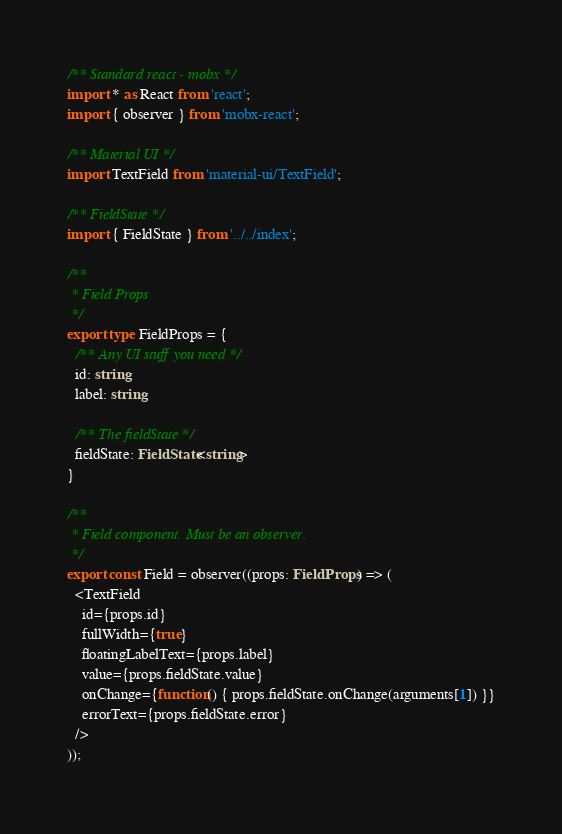<code> <loc_0><loc_0><loc_500><loc_500><_TypeScript_>/** Standard react - mobx */
import * as React from 'react';
import { observer } from 'mobx-react';

/** Material UI */
import TextField from 'material-ui/TextField';

/** FieldState */
import { FieldState } from '../../index';

/**
 * Field Props
 */
export type FieldProps = {
  /** Any UI stuff you need */
  id: string,
  label: string,

  /** The fieldState */
  fieldState: FieldState<string>
}

/**
 * Field component. Must be an observer.
 */
export const Field = observer((props: FieldProps) => (
  <TextField
    id={props.id}
    fullWidth={true}
    floatingLabelText={props.label}
    value={props.fieldState.value}
    onChange={function() { props.fieldState.onChange(arguments[1]) }}
    errorText={props.fieldState.error}
  />
));
</code> 